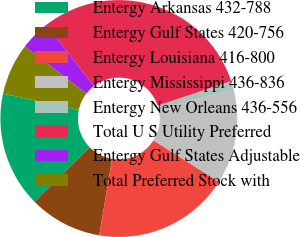<chart> <loc_0><loc_0><loc_500><loc_500><pie_chart><fcel>Entergy Arkansas 432-788<fcel>Entergy Gulf States 420-756<fcel>Entergy Louisiana 416-800<fcel>Entergy Mississippi 436-836<fcel>Entergy New Orleans 436-556<fcel>Total U S Utility Preferred<fcel>Entergy Gulf States Adjustable<fcel>Total Preferred Stock with<nl><fcel>15.77%<fcel>9.95%<fcel>18.68%<fcel>12.86%<fcel>1.22%<fcel>30.32%<fcel>4.13%<fcel>7.04%<nl></chart> 